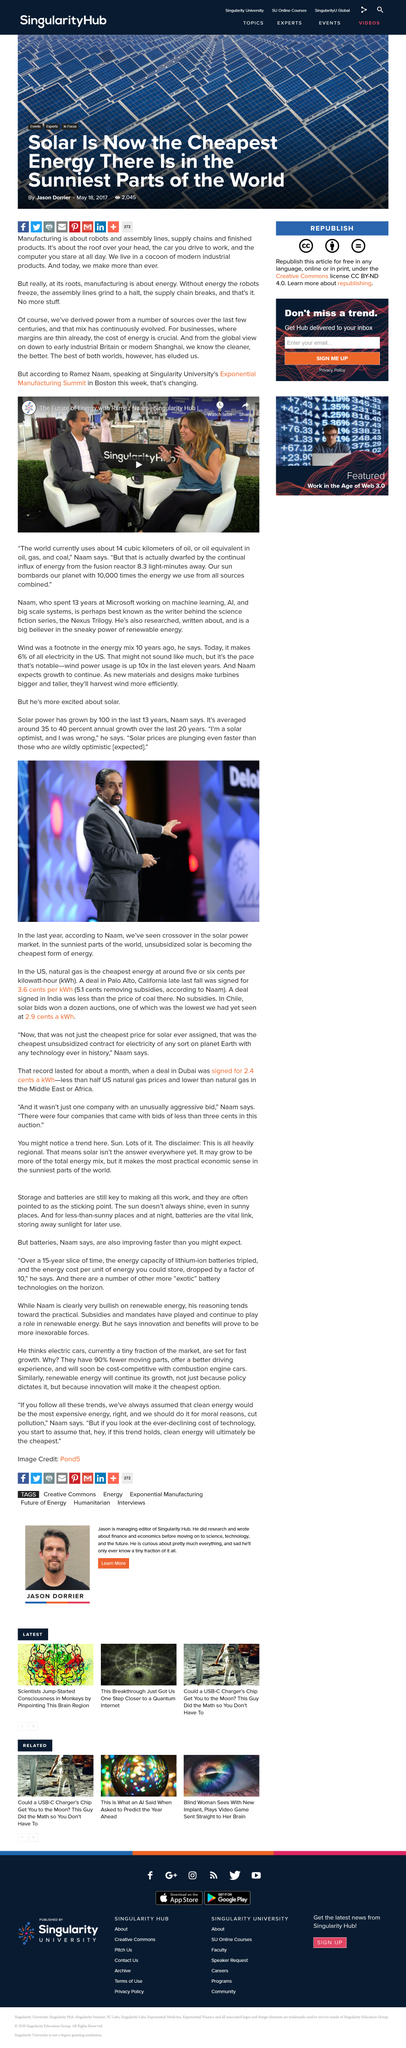Draw attention to some important aspects in this diagram. The cost of energy is a critical factor for businesses, as it directly impacts their financial stability and ability to compete in the market. Naam is pictured speaking in the photograph. The cheapest solar bid in Chile was 2.9 cents per kWh. Solar power has grown on average annually by 35 to 40 percent over the last 20 years. Manufacturing is a process that involves the use of robots, assembly lines, supply chains, and the production of finished products, all of which rely heavily on the use of energy. 